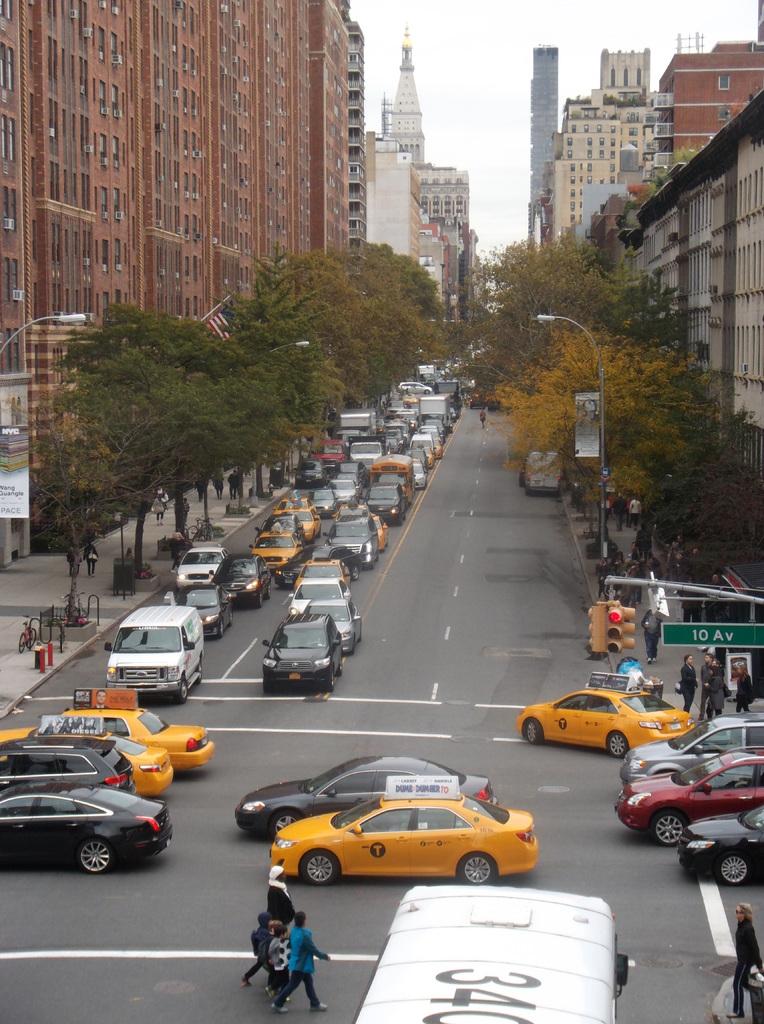What street is this picture taken at?
Your answer should be compact. 10 av. What number is on top of the bus?
Provide a short and direct response. 340. 